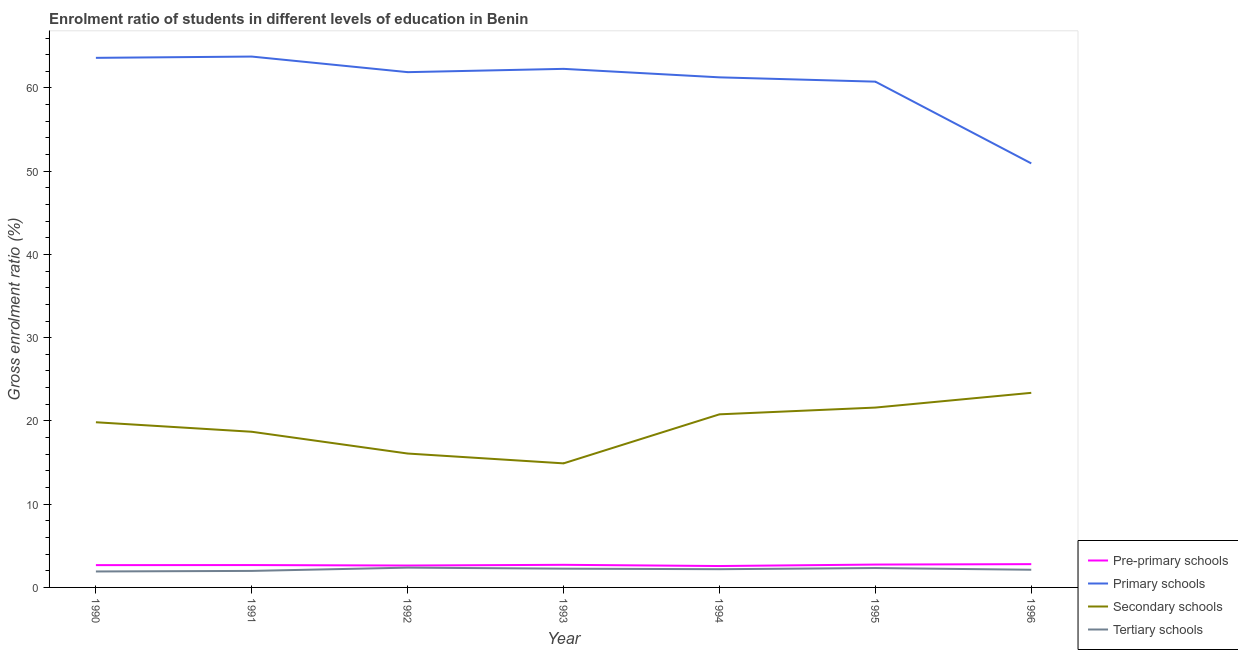Does the line corresponding to gross enrolment ratio in secondary schools intersect with the line corresponding to gross enrolment ratio in pre-primary schools?
Give a very brief answer. No. Is the number of lines equal to the number of legend labels?
Give a very brief answer. Yes. What is the gross enrolment ratio in secondary schools in 1992?
Give a very brief answer. 16.08. Across all years, what is the maximum gross enrolment ratio in primary schools?
Offer a very short reply. 63.77. Across all years, what is the minimum gross enrolment ratio in pre-primary schools?
Your answer should be very brief. 2.57. In which year was the gross enrolment ratio in secondary schools maximum?
Your response must be concise. 1996. What is the total gross enrolment ratio in pre-primary schools in the graph?
Offer a terse response. 18.83. What is the difference between the gross enrolment ratio in primary schools in 1995 and that in 1996?
Your answer should be compact. 9.82. What is the difference between the gross enrolment ratio in primary schools in 1991 and the gross enrolment ratio in secondary schools in 1990?
Your response must be concise. 43.93. What is the average gross enrolment ratio in primary schools per year?
Provide a short and direct response. 60.65. In the year 1992, what is the difference between the gross enrolment ratio in primary schools and gross enrolment ratio in pre-primary schools?
Your response must be concise. 59.27. In how many years, is the gross enrolment ratio in pre-primary schools greater than 22 %?
Provide a succinct answer. 0. What is the ratio of the gross enrolment ratio in secondary schools in 1992 to that in 1993?
Keep it short and to the point. 1.08. Is the gross enrolment ratio in secondary schools in 1993 less than that in 1995?
Your answer should be very brief. Yes. What is the difference between the highest and the second highest gross enrolment ratio in primary schools?
Keep it short and to the point. 0.15. What is the difference between the highest and the lowest gross enrolment ratio in secondary schools?
Make the answer very short. 8.47. In how many years, is the gross enrolment ratio in secondary schools greater than the average gross enrolment ratio in secondary schools taken over all years?
Ensure brevity in your answer.  4. Does the gross enrolment ratio in primary schools monotonically increase over the years?
Give a very brief answer. No. Is the gross enrolment ratio in secondary schools strictly greater than the gross enrolment ratio in tertiary schools over the years?
Your answer should be very brief. Yes. Is the gross enrolment ratio in secondary schools strictly less than the gross enrolment ratio in tertiary schools over the years?
Offer a terse response. No. How many lines are there?
Offer a terse response. 4. What is the difference between two consecutive major ticks on the Y-axis?
Offer a very short reply. 10. Are the values on the major ticks of Y-axis written in scientific E-notation?
Your response must be concise. No. Does the graph contain any zero values?
Offer a terse response. No. Does the graph contain grids?
Your response must be concise. No. What is the title of the graph?
Your answer should be compact. Enrolment ratio of students in different levels of education in Benin. Does "Luxembourg" appear as one of the legend labels in the graph?
Keep it short and to the point. No. What is the Gross enrolment ratio (%) in Pre-primary schools in 1990?
Ensure brevity in your answer.  2.68. What is the Gross enrolment ratio (%) of Primary schools in 1990?
Your answer should be very brief. 63.62. What is the Gross enrolment ratio (%) of Secondary schools in 1990?
Offer a very short reply. 19.84. What is the Gross enrolment ratio (%) in Tertiary schools in 1990?
Your answer should be very brief. 1.92. What is the Gross enrolment ratio (%) of Pre-primary schools in 1991?
Your answer should be very brief. 2.69. What is the Gross enrolment ratio (%) in Primary schools in 1991?
Your answer should be very brief. 63.77. What is the Gross enrolment ratio (%) of Secondary schools in 1991?
Keep it short and to the point. 18.7. What is the Gross enrolment ratio (%) in Tertiary schools in 1991?
Your response must be concise. 1.98. What is the Gross enrolment ratio (%) of Pre-primary schools in 1992?
Keep it short and to the point. 2.63. What is the Gross enrolment ratio (%) in Primary schools in 1992?
Offer a terse response. 61.9. What is the Gross enrolment ratio (%) of Secondary schools in 1992?
Your response must be concise. 16.08. What is the Gross enrolment ratio (%) in Tertiary schools in 1992?
Give a very brief answer. 2.38. What is the Gross enrolment ratio (%) in Pre-primary schools in 1993?
Provide a short and direct response. 2.72. What is the Gross enrolment ratio (%) of Primary schools in 1993?
Ensure brevity in your answer.  62.29. What is the Gross enrolment ratio (%) in Secondary schools in 1993?
Your answer should be compact. 14.9. What is the Gross enrolment ratio (%) in Tertiary schools in 1993?
Your answer should be compact. 2.26. What is the Gross enrolment ratio (%) in Pre-primary schools in 1994?
Keep it short and to the point. 2.57. What is the Gross enrolment ratio (%) of Primary schools in 1994?
Provide a succinct answer. 61.28. What is the Gross enrolment ratio (%) in Secondary schools in 1994?
Your response must be concise. 20.79. What is the Gross enrolment ratio (%) of Tertiary schools in 1994?
Offer a very short reply. 2.19. What is the Gross enrolment ratio (%) in Pre-primary schools in 1995?
Provide a succinct answer. 2.75. What is the Gross enrolment ratio (%) of Primary schools in 1995?
Ensure brevity in your answer.  60.76. What is the Gross enrolment ratio (%) in Secondary schools in 1995?
Provide a succinct answer. 21.61. What is the Gross enrolment ratio (%) in Tertiary schools in 1995?
Keep it short and to the point. 2.33. What is the Gross enrolment ratio (%) in Pre-primary schools in 1996?
Offer a very short reply. 2.8. What is the Gross enrolment ratio (%) in Primary schools in 1996?
Your answer should be compact. 50.94. What is the Gross enrolment ratio (%) of Secondary schools in 1996?
Your answer should be compact. 23.38. What is the Gross enrolment ratio (%) in Tertiary schools in 1996?
Give a very brief answer. 2.12. Across all years, what is the maximum Gross enrolment ratio (%) of Pre-primary schools?
Offer a terse response. 2.8. Across all years, what is the maximum Gross enrolment ratio (%) of Primary schools?
Offer a terse response. 63.77. Across all years, what is the maximum Gross enrolment ratio (%) of Secondary schools?
Provide a succinct answer. 23.38. Across all years, what is the maximum Gross enrolment ratio (%) of Tertiary schools?
Your answer should be very brief. 2.38. Across all years, what is the minimum Gross enrolment ratio (%) in Pre-primary schools?
Provide a succinct answer. 2.57. Across all years, what is the minimum Gross enrolment ratio (%) of Primary schools?
Provide a succinct answer. 50.94. Across all years, what is the minimum Gross enrolment ratio (%) of Secondary schools?
Keep it short and to the point. 14.9. Across all years, what is the minimum Gross enrolment ratio (%) of Tertiary schools?
Provide a succinct answer. 1.92. What is the total Gross enrolment ratio (%) in Pre-primary schools in the graph?
Offer a terse response. 18.83. What is the total Gross enrolment ratio (%) in Primary schools in the graph?
Offer a terse response. 424.55. What is the total Gross enrolment ratio (%) in Secondary schools in the graph?
Offer a very short reply. 135.3. What is the total Gross enrolment ratio (%) in Tertiary schools in the graph?
Make the answer very short. 15.17. What is the difference between the Gross enrolment ratio (%) in Pre-primary schools in 1990 and that in 1991?
Offer a very short reply. -0.01. What is the difference between the Gross enrolment ratio (%) of Primary schools in 1990 and that in 1991?
Give a very brief answer. -0.15. What is the difference between the Gross enrolment ratio (%) in Secondary schools in 1990 and that in 1991?
Your answer should be compact. 1.14. What is the difference between the Gross enrolment ratio (%) in Tertiary schools in 1990 and that in 1991?
Give a very brief answer. -0.07. What is the difference between the Gross enrolment ratio (%) in Pre-primary schools in 1990 and that in 1992?
Ensure brevity in your answer.  0.05. What is the difference between the Gross enrolment ratio (%) in Primary schools in 1990 and that in 1992?
Your answer should be very brief. 1.72. What is the difference between the Gross enrolment ratio (%) of Secondary schools in 1990 and that in 1992?
Keep it short and to the point. 3.76. What is the difference between the Gross enrolment ratio (%) of Tertiary schools in 1990 and that in 1992?
Keep it short and to the point. -0.46. What is the difference between the Gross enrolment ratio (%) of Pre-primary schools in 1990 and that in 1993?
Your answer should be compact. -0.04. What is the difference between the Gross enrolment ratio (%) in Primary schools in 1990 and that in 1993?
Your response must be concise. 1.32. What is the difference between the Gross enrolment ratio (%) of Secondary schools in 1990 and that in 1993?
Offer a terse response. 4.94. What is the difference between the Gross enrolment ratio (%) of Tertiary schools in 1990 and that in 1993?
Your answer should be compact. -0.34. What is the difference between the Gross enrolment ratio (%) of Pre-primary schools in 1990 and that in 1994?
Provide a short and direct response. 0.11. What is the difference between the Gross enrolment ratio (%) of Primary schools in 1990 and that in 1994?
Make the answer very short. 2.34. What is the difference between the Gross enrolment ratio (%) in Secondary schools in 1990 and that in 1994?
Make the answer very short. -0.95. What is the difference between the Gross enrolment ratio (%) in Tertiary schools in 1990 and that in 1994?
Offer a terse response. -0.27. What is the difference between the Gross enrolment ratio (%) of Pre-primary schools in 1990 and that in 1995?
Make the answer very short. -0.07. What is the difference between the Gross enrolment ratio (%) of Primary schools in 1990 and that in 1995?
Ensure brevity in your answer.  2.86. What is the difference between the Gross enrolment ratio (%) of Secondary schools in 1990 and that in 1995?
Offer a terse response. -1.76. What is the difference between the Gross enrolment ratio (%) of Tertiary schools in 1990 and that in 1995?
Your response must be concise. -0.41. What is the difference between the Gross enrolment ratio (%) in Pre-primary schools in 1990 and that in 1996?
Your answer should be compact. -0.12. What is the difference between the Gross enrolment ratio (%) in Primary schools in 1990 and that in 1996?
Give a very brief answer. 12.68. What is the difference between the Gross enrolment ratio (%) of Secondary schools in 1990 and that in 1996?
Provide a short and direct response. -3.53. What is the difference between the Gross enrolment ratio (%) in Tertiary schools in 1990 and that in 1996?
Make the answer very short. -0.21. What is the difference between the Gross enrolment ratio (%) in Pre-primary schools in 1991 and that in 1992?
Ensure brevity in your answer.  0.06. What is the difference between the Gross enrolment ratio (%) in Primary schools in 1991 and that in 1992?
Your response must be concise. 1.87. What is the difference between the Gross enrolment ratio (%) in Secondary schools in 1991 and that in 1992?
Ensure brevity in your answer.  2.62. What is the difference between the Gross enrolment ratio (%) in Tertiary schools in 1991 and that in 1992?
Your answer should be compact. -0.39. What is the difference between the Gross enrolment ratio (%) in Pre-primary schools in 1991 and that in 1993?
Keep it short and to the point. -0.03. What is the difference between the Gross enrolment ratio (%) of Primary schools in 1991 and that in 1993?
Give a very brief answer. 1.48. What is the difference between the Gross enrolment ratio (%) in Secondary schools in 1991 and that in 1993?
Provide a succinct answer. 3.8. What is the difference between the Gross enrolment ratio (%) in Tertiary schools in 1991 and that in 1993?
Offer a terse response. -0.27. What is the difference between the Gross enrolment ratio (%) of Pre-primary schools in 1991 and that in 1994?
Offer a terse response. 0.12. What is the difference between the Gross enrolment ratio (%) of Primary schools in 1991 and that in 1994?
Make the answer very short. 2.5. What is the difference between the Gross enrolment ratio (%) in Secondary schools in 1991 and that in 1994?
Give a very brief answer. -2.09. What is the difference between the Gross enrolment ratio (%) of Tertiary schools in 1991 and that in 1994?
Provide a succinct answer. -0.2. What is the difference between the Gross enrolment ratio (%) in Pre-primary schools in 1991 and that in 1995?
Offer a terse response. -0.06. What is the difference between the Gross enrolment ratio (%) of Primary schools in 1991 and that in 1995?
Make the answer very short. 3.01. What is the difference between the Gross enrolment ratio (%) in Secondary schools in 1991 and that in 1995?
Ensure brevity in your answer.  -2.91. What is the difference between the Gross enrolment ratio (%) of Tertiary schools in 1991 and that in 1995?
Make the answer very short. -0.34. What is the difference between the Gross enrolment ratio (%) in Pre-primary schools in 1991 and that in 1996?
Make the answer very short. -0.11. What is the difference between the Gross enrolment ratio (%) of Primary schools in 1991 and that in 1996?
Keep it short and to the point. 12.83. What is the difference between the Gross enrolment ratio (%) of Secondary schools in 1991 and that in 1996?
Give a very brief answer. -4.68. What is the difference between the Gross enrolment ratio (%) in Tertiary schools in 1991 and that in 1996?
Keep it short and to the point. -0.14. What is the difference between the Gross enrolment ratio (%) in Pre-primary schools in 1992 and that in 1993?
Your answer should be very brief. -0.09. What is the difference between the Gross enrolment ratio (%) of Primary schools in 1992 and that in 1993?
Offer a very short reply. -0.4. What is the difference between the Gross enrolment ratio (%) of Secondary schools in 1992 and that in 1993?
Give a very brief answer. 1.18. What is the difference between the Gross enrolment ratio (%) of Tertiary schools in 1992 and that in 1993?
Your answer should be very brief. 0.12. What is the difference between the Gross enrolment ratio (%) in Pre-primary schools in 1992 and that in 1994?
Provide a succinct answer. 0.06. What is the difference between the Gross enrolment ratio (%) of Primary schools in 1992 and that in 1994?
Provide a short and direct response. 0.62. What is the difference between the Gross enrolment ratio (%) of Secondary schools in 1992 and that in 1994?
Your answer should be compact. -4.71. What is the difference between the Gross enrolment ratio (%) of Tertiary schools in 1992 and that in 1994?
Your answer should be very brief. 0.19. What is the difference between the Gross enrolment ratio (%) of Pre-primary schools in 1992 and that in 1995?
Your response must be concise. -0.12. What is the difference between the Gross enrolment ratio (%) in Primary schools in 1992 and that in 1995?
Give a very brief answer. 1.14. What is the difference between the Gross enrolment ratio (%) in Secondary schools in 1992 and that in 1995?
Provide a short and direct response. -5.52. What is the difference between the Gross enrolment ratio (%) of Tertiary schools in 1992 and that in 1995?
Offer a terse response. 0.05. What is the difference between the Gross enrolment ratio (%) of Pre-primary schools in 1992 and that in 1996?
Your response must be concise. -0.17. What is the difference between the Gross enrolment ratio (%) of Primary schools in 1992 and that in 1996?
Your answer should be compact. 10.96. What is the difference between the Gross enrolment ratio (%) in Secondary schools in 1992 and that in 1996?
Your response must be concise. -7.29. What is the difference between the Gross enrolment ratio (%) of Tertiary schools in 1992 and that in 1996?
Your answer should be compact. 0.26. What is the difference between the Gross enrolment ratio (%) of Pre-primary schools in 1993 and that in 1994?
Your answer should be very brief. 0.15. What is the difference between the Gross enrolment ratio (%) of Primary schools in 1993 and that in 1994?
Ensure brevity in your answer.  1.02. What is the difference between the Gross enrolment ratio (%) in Secondary schools in 1993 and that in 1994?
Ensure brevity in your answer.  -5.89. What is the difference between the Gross enrolment ratio (%) of Tertiary schools in 1993 and that in 1994?
Make the answer very short. 0.07. What is the difference between the Gross enrolment ratio (%) of Pre-primary schools in 1993 and that in 1995?
Provide a succinct answer. -0.03. What is the difference between the Gross enrolment ratio (%) of Primary schools in 1993 and that in 1995?
Make the answer very short. 1.54. What is the difference between the Gross enrolment ratio (%) in Secondary schools in 1993 and that in 1995?
Offer a very short reply. -6.7. What is the difference between the Gross enrolment ratio (%) of Tertiary schools in 1993 and that in 1995?
Your answer should be compact. -0.07. What is the difference between the Gross enrolment ratio (%) of Pre-primary schools in 1993 and that in 1996?
Offer a very short reply. -0.08. What is the difference between the Gross enrolment ratio (%) of Primary schools in 1993 and that in 1996?
Your answer should be compact. 11.36. What is the difference between the Gross enrolment ratio (%) of Secondary schools in 1993 and that in 1996?
Provide a short and direct response. -8.47. What is the difference between the Gross enrolment ratio (%) of Tertiary schools in 1993 and that in 1996?
Make the answer very short. 0.13. What is the difference between the Gross enrolment ratio (%) in Pre-primary schools in 1994 and that in 1995?
Offer a terse response. -0.18. What is the difference between the Gross enrolment ratio (%) of Primary schools in 1994 and that in 1995?
Provide a short and direct response. 0.52. What is the difference between the Gross enrolment ratio (%) of Secondary schools in 1994 and that in 1995?
Provide a succinct answer. -0.81. What is the difference between the Gross enrolment ratio (%) of Tertiary schools in 1994 and that in 1995?
Offer a terse response. -0.14. What is the difference between the Gross enrolment ratio (%) of Pre-primary schools in 1994 and that in 1996?
Ensure brevity in your answer.  -0.23. What is the difference between the Gross enrolment ratio (%) in Primary schools in 1994 and that in 1996?
Ensure brevity in your answer.  10.34. What is the difference between the Gross enrolment ratio (%) of Secondary schools in 1994 and that in 1996?
Ensure brevity in your answer.  -2.58. What is the difference between the Gross enrolment ratio (%) in Tertiary schools in 1994 and that in 1996?
Make the answer very short. 0.07. What is the difference between the Gross enrolment ratio (%) in Pre-primary schools in 1995 and that in 1996?
Your answer should be very brief. -0.05. What is the difference between the Gross enrolment ratio (%) in Primary schools in 1995 and that in 1996?
Provide a succinct answer. 9.82. What is the difference between the Gross enrolment ratio (%) in Secondary schools in 1995 and that in 1996?
Your response must be concise. -1.77. What is the difference between the Gross enrolment ratio (%) in Tertiary schools in 1995 and that in 1996?
Your answer should be very brief. 0.21. What is the difference between the Gross enrolment ratio (%) in Pre-primary schools in 1990 and the Gross enrolment ratio (%) in Primary schools in 1991?
Keep it short and to the point. -61.09. What is the difference between the Gross enrolment ratio (%) of Pre-primary schools in 1990 and the Gross enrolment ratio (%) of Secondary schools in 1991?
Offer a terse response. -16.02. What is the difference between the Gross enrolment ratio (%) of Pre-primary schools in 1990 and the Gross enrolment ratio (%) of Tertiary schools in 1991?
Your answer should be very brief. 0.69. What is the difference between the Gross enrolment ratio (%) in Primary schools in 1990 and the Gross enrolment ratio (%) in Secondary schools in 1991?
Make the answer very short. 44.92. What is the difference between the Gross enrolment ratio (%) of Primary schools in 1990 and the Gross enrolment ratio (%) of Tertiary schools in 1991?
Keep it short and to the point. 61.63. What is the difference between the Gross enrolment ratio (%) of Secondary schools in 1990 and the Gross enrolment ratio (%) of Tertiary schools in 1991?
Your response must be concise. 17.86. What is the difference between the Gross enrolment ratio (%) in Pre-primary schools in 1990 and the Gross enrolment ratio (%) in Primary schools in 1992?
Make the answer very short. -59.22. What is the difference between the Gross enrolment ratio (%) of Pre-primary schools in 1990 and the Gross enrolment ratio (%) of Secondary schools in 1992?
Offer a very short reply. -13.4. What is the difference between the Gross enrolment ratio (%) in Pre-primary schools in 1990 and the Gross enrolment ratio (%) in Tertiary schools in 1992?
Your answer should be compact. 0.3. What is the difference between the Gross enrolment ratio (%) of Primary schools in 1990 and the Gross enrolment ratio (%) of Secondary schools in 1992?
Provide a short and direct response. 47.53. What is the difference between the Gross enrolment ratio (%) in Primary schools in 1990 and the Gross enrolment ratio (%) in Tertiary schools in 1992?
Ensure brevity in your answer.  61.24. What is the difference between the Gross enrolment ratio (%) of Secondary schools in 1990 and the Gross enrolment ratio (%) of Tertiary schools in 1992?
Provide a short and direct response. 17.46. What is the difference between the Gross enrolment ratio (%) of Pre-primary schools in 1990 and the Gross enrolment ratio (%) of Primary schools in 1993?
Your answer should be compact. -59.62. What is the difference between the Gross enrolment ratio (%) of Pre-primary schools in 1990 and the Gross enrolment ratio (%) of Secondary schools in 1993?
Keep it short and to the point. -12.22. What is the difference between the Gross enrolment ratio (%) in Pre-primary schools in 1990 and the Gross enrolment ratio (%) in Tertiary schools in 1993?
Offer a terse response. 0.42. What is the difference between the Gross enrolment ratio (%) of Primary schools in 1990 and the Gross enrolment ratio (%) of Secondary schools in 1993?
Your answer should be very brief. 48.71. What is the difference between the Gross enrolment ratio (%) in Primary schools in 1990 and the Gross enrolment ratio (%) in Tertiary schools in 1993?
Your answer should be compact. 61.36. What is the difference between the Gross enrolment ratio (%) in Secondary schools in 1990 and the Gross enrolment ratio (%) in Tertiary schools in 1993?
Offer a very short reply. 17.59. What is the difference between the Gross enrolment ratio (%) in Pre-primary schools in 1990 and the Gross enrolment ratio (%) in Primary schools in 1994?
Your answer should be compact. -58.6. What is the difference between the Gross enrolment ratio (%) in Pre-primary schools in 1990 and the Gross enrolment ratio (%) in Secondary schools in 1994?
Provide a succinct answer. -18.11. What is the difference between the Gross enrolment ratio (%) in Pre-primary schools in 1990 and the Gross enrolment ratio (%) in Tertiary schools in 1994?
Your answer should be compact. 0.49. What is the difference between the Gross enrolment ratio (%) of Primary schools in 1990 and the Gross enrolment ratio (%) of Secondary schools in 1994?
Provide a succinct answer. 42.82. What is the difference between the Gross enrolment ratio (%) in Primary schools in 1990 and the Gross enrolment ratio (%) in Tertiary schools in 1994?
Provide a succinct answer. 61.43. What is the difference between the Gross enrolment ratio (%) in Secondary schools in 1990 and the Gross enrolment ratio (%) in Tertiary schools in 1994?
Make the answer very short. 17.65. What is the difference between the Gross enrolment ratio (%) of Pre-primary schools in 1990 and the Gross enrolment ratio (%) of Primary schools in 1995?
Offer a terse response. -58.08. What is the difference between the Gross enrolment ratio (%) of Pre-primary schools in 1990 and the Gross enrolment ratio (%) of Secondary schools in 1995?
Give a very brief answer. -18.93. What is the difference between the Gross enrolment ratio (%) of Pre-primary schools in 1990 and the Gross enrolment ratio (%) of Tertiary schools in 1995?
Your answer should be compact. 0.35. What is the difference between the Gross enrolment ratio (%) in Primary schools in 1990 and the Gross enrolment ratio (%) in Secondary schools in 1995?
Keep it short and to the point. 42.01. What is the difference between the Gross enrolment ratio (%) of Primary schools in 1990 and the Gross enrolment ratio (%) of Tertiary schools in 1995?
Give a very brief answer. 61.29. What is the difference between the Gross enrolment ratio (%) in Secondary schools in 1990 and the Gross enrolment ratio (%) in Tertiary schools in 1995?
Offer a terse response. 17.51. What is the difference between the Gross enrolment ratio (%) of Pre-primary schools in 1990 and the Gross enrolment ratio (%) of Primary schools in 1996?
Make the answer very short. -48.26. What is the difference between the Gross enrolment ratio (%) of Pre-primary schools in 1990 and the Gross enrolment ratio (%) of Secondary schools in 1996?
Provide a succinct answer. -20.7. What is the difference between the Gross enrolment ratio (%) of Pre-primary schools in 1990 and the Gross enrolment ratio (%) of Tertiary schools in 1996?
Your answer should be compact. 0.56. What is the difference between the Gross enrolment ratio (%) in Primary schools in 1990 and the Gross enrolment ratio (%) in Secondary schools in 1996?
Provide a short and direct response. 40.24. What is the difference between the Gross enrolment ratio (%) in Primary schools in 1990 and the Gross enrolment ratio (%) in Tertiary schools in 1996?
Offer a terse response. 61.5. What is the difference between the Gross enrolment ratio (%) in Secondary schools in 1990 and the Gross enrolment ratio (%) in Tertiary schools in 1996?
Give a very brief answer. 17.72. What is the difference between the Gross enrolment ratio (%) in Pre-primary schools in 1991 and the Gross enrolment ratio (%) in Primary schools in 1992?
Ensure brevity in your answer.  -59.21. What is the difference between the Gross enrolment ratio (%) of Pre-primary schools in 1991 and the Gross enrolment ratio (%) of Secondary schools in 1992?
Make the answer very short. -13.4. What is the difference between the Gross enrolment ratio (%) of Pre-primary schools in 1991 and the Gross enrolment ratio (%) of Tertiary schools in 1992?
Offer a terse response. 0.31. What is the difference between the Gross enrolment ratio (%) in Primary schools in 1991 and the Gross enrolment ratio (%) in Secondary schools in 1992?
Your response must be concise. 47.69. What is the difference between the Gross enrolment ratio (%) of Primary schools in 1991 and the Gross enrolment ratio (%) of Tertiary schools in 1992?
Offer a very short reply. 61.39. What is the difference between the Gross enrolment ratio (%) of Secondary schools in 1991 and the Gross enrolment ratio (%) of Tertiary schools in 1992?
Offer a terse response. 16.32. What is the difference between the Gross enrolment ratio (%) in Pre-primary schools in 1991 and the Gross enrolment ratio (%) in Primary schools in 1993?
Provide a short and direct response. -59.61. What is the difference between the Gross enrolment ratio (%) in Pre-primary schools in 1991 and the Gross enrolment ratio (%) in Secondary schools in 1993?
Make the answer very short. -12.22. What is the difference between the Gross enrolment ratio (%) in Pre-primary schools in 1991 and the Gross enrolment ratio (%) in Tertiary schools in 1993?
Your answer should be very brief. 0.43. What is the difference between the Gross enrolment ratio (%) of Primary schools in 1991 and the Gross enrolment ratio (%) of Secondary schools in 1993?
Provide a short and direct response. 48.87. What is the difference between the Gross enrolment ratio (%) in Primary schools in 1991 and the Gross enrolment ratio (%) in Tertiary schools in 1993?
Ensure brevity in your answer.  61.52. What is the difference between the Gross enrolment ratio (%) of Secondary schools in 1991 and the Gross enrolment ratio (%) of Tertiary schools in 1993?
Provide a succinct answer. 16.44. What is the difference between the Gross enrolment ratio (%) in Pre-primary schools in 1991 and the Gross enrolment ratio (%) in Primary schools in 1994?
Provide a short and direct response. -58.59. What is the difference between the Gross enrolment ratio (%) of Pre-primary schools in 1991 and the Gross enrolment ratio (%) of Secondary schools in 1994?
Give a very brief answer. -18.11. What is the difference between the Gross enrolment ratio (%) of Pre-primary schools in 1991 and the Gross enrolment ratio (%) of Tertiary schools in 1994?
Your response must be concise. 0.5. What is the difference between the Gross enrolment ratio (%) in Primary schools in 1991 and the Gross enrolment ratio (%) in Secondary schools in 1994?
Your answer should be compact. 42.98. What is the difference between the Gross enrolment ratio (%) of Primary schools in 1991 and the Gross enrolment ratio (%) of Tertiary schools in 1994?
Offer a very short reply. 61.58. What is the difference between the Gross enrolment ratio (%) of Secondary schools in 1991 and the Gross enrolment ratio (%) of Tertiary schools in 1994?
Your answer should be very brief. 16.51. What is the difference between the Gross enrolment ratio (%) in Pre-primary schools in 1991 and the Gross enrolment ratio (%) in Primary schools in 1995?
Keep it short and to the point. -58.07. What is the difference between the Gross enrolment ratio (%) in Pre-primary schools in 1991 and the Gross enrolment ratio (%) in Secondary schools in 1995?
Keep it short and to the point. -18.92. What is the difference between the Gross enrolment ratio (%) in Pre-primary schools in 1991 and the Gross enrolment ratio (%) in Tertiary schools in 1995?
Your answer should be very brief. 0.36. What is the difference between the Gross enrolment ratio (%) in Primary schools in 1991 and the Gross enrolment ratio (%) in Secondary schools in 1995?
Provide a succinct answer. 42.16. What is the difference between the Gross enrolment ratio (%) of Primary schools in 1991 and the Gross enrolment ratio (%) of Tertiary schools in 1995?
Offer a very short reply. 61.44. What is the difference between the Gross enrolment ratio (%) of Secondary schools in 1991 and the Gross enrolment ratio (%) of Tertiary schools in 1995?
Provide a short and direct response. 16.37. What is the difference between the Gross enrolment ratio (%) of Pre-primary schools in 1991 and the Gross enrolment ratio (%) of Primary schools in 1996?
Your answer should be compact. -48.25. What is the difference between the Gross enrolment ratio (%) of Pre-primary schools in 1991 and the Gross enrolment ratio (%) of Secondary schools in 1996?
Give a very brief answer. -20.69. What is the difference between the Gross enrolment ratio (%) of Pre-primary schools in 1991 and the Gross enrolment ratio (%) of Tertiary schools in 1996?
Your response must be concise. 0.56. What is the difference between the Gross enrolment ratio (%) of Primary schools in 1991 and the Gross enrolment ratio (%) of Secondary schools in 1996?
Keep it short and to the point. 40.39. What is the difference between the Gross enrolment ratio (%) of Primary schools in 1991 and the Gross enrolment ratio (%) of Tertiary schools in 1996?
Provide a succinct answer. 61.65. What is the difference between the Gross enrolment ratio (%) of Secondary schools in 1991 and the Gross enrolment ratio (%) of Tertiary schools in 1996?
Make the answer very short. 16.58. What is the difference between the Gross enrolment ratio (%) in Pre-primary schools in 1992 and the Gross enrolment ratio (%) in Primary schools in 1993?
Your answer should be compact. -59.66. What is the difference between the Gross enrolment ratio (%) in Pre-primary schools in 1992 and the Gross enrolment ratio (%) in Secondary schools in 1993?
Provide a succinct answer. -12.27. What is the difference between the Gross enrolment ratio (%) of Pre-primary schools in 1992 and the Gross enrolment ratio (%) of Tertiary schools in 1993?
Your answer should be compact. 0.37. What is the difference between the Gross enrolment ratio (%) of Primary schools in 1992 and the Gross enrolment ratio (%) of Secondary schools in 1993?
Your answer should be compact. 47. What is the difference between the Gross enrolment ratio (%) in Primary schools in 1992 and the Gross enrolment ratio (%) in Tertiary schools in 1993?
Your response must be concise. 59.64. What is the difference between the Gross enrolment ratio (%) in Secondary schools in 1992 and the Gross enrolment ratio (%) in Tertiary schools in 1993?
Give a very brief answer. 13.83. What is the difference between the Gross enrolment ratio (%) of Pre-primary schools in 1992 and the Gross enrolment ratio (%) of Primary schools in 1994?
Keep it short and to the point. -58.65. What is the difference between the Gross enrolment ratio (%) in Pre-primary schools in 1992 and the Gross enrolment ratio (%) in Secondary schools in 1994?
Keep it short and to the point. -18.16. What is the difference between the Gross enrolment ratio (%) of Pre-primary schools in 1992 and the Gross enrolment ratio (%) of Tertiary schools in 1994?
Keep it short and to the point. 0.44. What is the difference between the Gross enrolment ratio (%) in Primary schools in 1992 and the Gross enrolment ratio (%) in Secondary schools in 1994?
Keep it short and to the point. 41.1. What is the difference between the Gross enrolment ratio (%) in Primary schools in 1992 and the Gross enrolment ratio (%) in Tertiary schools in 1994?
Provide a short and direct response. 59.71. What is the difference between the Gross enrolment ratio (%) in Secondary schools in 1992 and the Gross enrolment ratio (%) in Tertiary schools in 1994?
Give a very brief answer. 13.9. What is the difference between the Gross enrolment ratio (%) in Pre-primary schools in 1992 and the Gross enrolment ratio (%) in Primary schools in 1995?
Provide a succinct answer. -58.13. What is the difference between the Gross enrolment ratio (%) of Pre-primary schools in 1992 and the Gross enrolment ratio (%) of Secondary schools in 1995?
Your response must be concise. -18.98. What is the difference between the Gross enrolment ratio (%) of Pre-primary schools in 1992 and the Gross enrolment ratio (%) of Tertiary schools in 1995?
Provide a short and direct response. 0.3. What is the difference between the Gross enrolment ratio (%) in Primary schools in 1992 and the Gross enrolment ratio (%) in Secondary schools in 1995?
Offer a very short reply. 40.29. What is the difference between the Gross enrolment ratio (%) of Primary schools in 1992 and the Gross enrolment ratio (%) of Tertiary schools in 1995?
Offer a terse response. 59.57. What is the difference between the Gross enrolment ratio (%) in Secondary schools in 1992 and the Gross enrolment ratio (%) in Tertiary schools in 1995?
Provide a succinct answer. 13.76. What is the difference between the Gross enrolment ratio (%) of Pre-primary schools in 1992 and the Gross enrolment ratio (%) of Primary schools in 1996?
Provide a short and direct response. -48.31. What is the difference between the Gross enrolment ratio (%) of Pre-primary schools in 1992 and the Gross enrolment ratio (%) of Secondary schools in 1996?
Your answer should be very brief. -20.75. What is the difference between the Gross enrolment ratio (%) of Pre-primary schools in 1992 and the Gross enrolment ratio (%) of Tertiary schools in 1996?
Your answer should be very brief. 0.51. What is the difference between the Gross enrolment ratio (%) of Primary schools in 1992 and the Gross enrolment ratio (%) of Secondary schools in 1996?
Provide a succinct answer. 38.52. What is the difference between the Gross enrolment ratio (%) of Primary schools in 1992 and the Gross enrolment ratio (%) of Tertiary schools in 1996?
Ensure brevity in your answer.  59.78. What is the difference between the Gross enrolment ratio (%) of Secondary schools in 1992 and the Gross enrolment ratio (%) of Tertiary schools in 1996?
Offer a terse response. 13.96. What is the difference between the Gross enrolment ratio (%) of Pre-primary schools in 1993 and the Gross enrolment ratio (%) of Primary schools in 1994?
Your answer should be compact. -58.56. What is the difference between the Gross enrolment ratio (%) of Pre-primary schools in 1993 and the Gross enrolment ratio (%) of Secondary schools in 1994?
Provide a succinct answer. -18.08. What is the difference between the Gross enrolment ratio (%) in Pre-primary schools in 1993 and the Gross enrolment ratio (%) in Tertiary schools in 1994?
Keep it short and to the point. 0.53. What is the difference between the Gross enrolment ratio (%) of Primary schools in 1993 and the Gross enrolment ratio (%) of Secondary schools in 1994?
Make the answer very short. 41.5. What is the difference between the Gross enrolment ratio (%) in Primary schools in 1993 and the Gross enrolment ratio (%) in Tertiary schools in 1994?
Ensure brevity in your answer.  60.11. What is the difference between the Gross enrolment ratio (%) in Secondary schools in 1993 and the Gross enrolment ratio (%) in Tertiary schools in 1994?
Offer a very short reply. 12.71. What is the difference between the Gross enrolment ratio (%) in Pre-primary schools in 1993 and the Gross enrolment ratio (%) in Primary schools in 1995?
Provide a succinct answer. -58.04. What is the difference between the Gross enrolment ratio (%) in Pre-primary schools in 1993 and the Gross enrolment ratio (%) in Secondary schools in 1995?
Give a very brief answer. -18.89. What is the difference between the Gross enrolment ratio (%) in Pre-primary schools in 1993 and the Gross enrolment ratio (%) in Tertiary schools in 1995?
Give a very brief answer. 0.39. What is the difference between the Gross enrolment ratio (%) in Primary schools in 1993 and the Gross enrolment ratio (%) in Secondary schools in 1995?
Offer a terse response. 40.69. What is the difference between the Gross enrolment ratio (%) of Primary schools in 1993 and the Gross enrolment ratio (%) of Tertiary schools in 1995?
Keep it short and to the point. 59.97. What is the difference between the Gross enrolment ratio (%) of Secondary schools in 1993 and the Gross enrolment ratio (%) of Tertiary schools in 1995?
Your response must be concise. 12.57. What is the difference between the Gross enrolment ratio (%) in Pre-primary schools in 1993 and the Gross enrolment ratio (%) in Primary schools in 1996?
Your answer should be very brief. -48.22. What is the difference between the Gross enrolment ratio (%) in Pre-primary schools in 1993 and the Gross enrolment ratio (%) in Secondary schools in 1996?
Keep it short and to the point. -20.66. What is the difference between the Gross enrolment ratio (%) in Pre-primary schools in 1993 and the Gross enrolment ratio (%) in Tertiary schools in 1996?
Your answer should be very brief. 0.59. What is the difference between the Gross enrolment ratio (%) in Primary schools in 1993 and the Gross enrolment ratio (%) in Secondary schools in 1996?
Your answer should be very brief. 38.92. What is the difference between the Gross enrolment ratio (%) of Primary schools in 1993 and the Gross enrolment ratio (%) of Tertiary schools in 1996?
Make the answer very short. 60.17. What is the difference between the Gross enrolment ratio (%) of Secondary schools in 1993 and the Gross enrolment ratio (%) of Tertiary schools in 1996?
Your answer should be very brief. 12.78. What is the difference between the Gross enrolment ratio (%) of Pre-primary schools in 1994 and the Gross enrolment ratio (%) of Primary schools in 1995?
Ensure brevity in your answer.  -58.19. What is the difference between the Gross enrolment ratio (%) of Pre-primary schools in 1994 and the Gross enrolment ratio (%) of Secondary schools in 1995?
Your answer should be very brief. -19.04. What is the difference between the Gross enrolment ratio (%) of Pre-primary schools in 1994 and the Gross enrolment ratio (%) of Tertiary schools in 1995?
Give a very brief answer. 0.24. What is the difference between the Gross enrolment ratio (%) in Primary schools in 1994 and the Gross enrolment ratio (%) in Secondary schools in 1995?
Offer a very short reply. 39.67. What is the difference between the Gross enrolment ratio (%) in Primary schools in 1994 and the Gross enrolment ratio (%) in Tertiary schools in 1995?
Offer a terse response. 58.95. What is the difference between the Gross enrolment ratio (%) in Secondary schools in 1994 and the Gross enrolment ratio (%) in Tertiary schools in 1995?
Ensure brevity in your answer.  18.47. What is the difference between the Gross enrolment ratio (%) in Pre-primary schools in 1994 and the Gross enrolment ratio (%) in Primary schools in 1996?
Ensure brevity in your answer.  -48.37. What is the difference between the Gross enrolment ratio (%) in Pre-primary schools in 1994 and the Gross enrolment ratio (%) in Secondary schools in 1996?
Offer a very short reply. -20.81. What is the difference between the Gross enrolment ratio (%) of Pre-primary schools in 1994 and the Gross enrolment ratio (%) of Tertiary schools in 1996?
Your response must be concise. 0.45. What is the difference between the Gross enrolment ratio (%) of Primary schools in 1994 and the Gross enrolment ratio (%) of Secondary schools in 1996?
Your answer should be very brief. 37.9. What is the difference between the Gross enrolment ratio (%) of Primary schools in 1994 and the Gross enrolment ratio (%) of Tertiary schools in 1996?
Your response must be concise. 59.15. What is the difference between the Gross enrolment ratio (%) in Secondary schools in 1994 and the Gross enrolment ratio (%) in Tertiary schools in 1996?
Offer a very short reply. 18.67. What is the difference between the Gross enrolment ratio (%) in Pre-primary schools in 1995 and the Gross enrolment ratio (%) in Primary schools in 1996?
Your response must be concise. -48.19. What is the difference between the Gross enrolment ratio (%) in Pre-primary schools in 1995 and the Gross enrolment ratio (%) in Secondary schools in 1996?
Provide a short and direct response. -20.63. What is the difference between the Gross enrolment ratio (%) in Pre-primary schools in 1995 and the Gross enrolment ratio (%) in Tertiary schools in 1996?
Offer a very short reply. 0.62. What is the difference between the Gross enrolment ratio (%) of Primary schools in 1995 and the Gross enrolment ratio (%) of Secondary schools in 1996?
Keep it short and to the point. 37.38. What is the difference between the Gross enrolment ratio (%) in Primary schools in 1995 and the Gross enrolment ratio (%) in Tertiary schools in 1996?
Offer a very short reply. 58.64. What is the difference between the Gross enrolment ratio (%) in Secondary schools in 1995 and the Gross enrolment ratio (%) in Tertiary schools in 1996?
Your response must be concise. 19.48. What is the average Gross enrolment ratio (%) in Pre-primary schools per year?
Offer a very short reply. 2.69. What is the average Gross enrolment ratio (%) of Primary schools per year?
Offer a terse response. 60.65. What is the average Gross enrolment ratio (%) in Secondary schools per year?
Offer a very short reply. 19.33. What is the average Gross enrolment ratio (%) of Tertiary schools per year?
Your response must be concise. 2.17. In the year 1990, what is the difference between the Gross enrolment ratio (%) in Pre-primary schools and Gross enrolment ratio (%) in Primary schools?
Your response must be concise. -60.94. In the year 1990, what is the difference between the Gross enrolment ratio (%) of Pre-primary schools and Gross enrolment ratio (%) of Secondary schools?
Offer a very short reply. -17.16. In the year 1990, what is the difference between the Gross enrolment ratio (%) in Pre-primary schools and Gross enrolment ratio (%) in Tertiary schools?
Ensure brevity in your answer.  0.76. In the year 1990, what is the difference between the Gross enrolment ratio (%) in Primary schools and Gross enrolment ratio (%) in Secondary schools?
Keep it short and to the point. 43.78. In the year 1990, what is the difference between the Gross enrolment ratio (%) of Primary schools and Gross enrolment ratio (%) of Tertiary schools?
Offer a very short reply. 61.7. In the year 1990, what is the difference between the Gross enrolment ratio (%) in Secondary schools and Gross enrolment ratio (%) in Tertiary schools?
Your response must be concise. 17.92. In the year 1991, what is the difference between the Gross enrolment ratio (%) of Pre-primary schools and Gross enrolment ratio (%) of Primary schools?
Your answer should be compact. -61.08. In the year 1991, what is the difference between the Gross enrolment ratio (%) of Pre-primary schools and Gross enrolment ratio (%) of Secondary schools?
Keep it short and to the point. -16.01. In the year 1991, what is the difference between the Gross enrolment ratio (%) of Pre-primary schools and Gross enrolment ratio (%) of Tertiary schools?
Offer a very short reply. 0.7. In the year 1991, what is the difference between the Gross enrolment ratio (%) in Primary schools and Gross enrolment ratio (%) in Secondary schools?
Make the answer very short. 45.07. In the year 1991, what is the difference between the Gross enrolment ratio (%) of Primary schools and Gross enrolment ratio (%) of Tertiary schools?
Give a very brief answer. 61.79. In the year 1991, what is the difference between the Gross enrolment ratio (%) of Secondary schools and Gross enrolment ratio (%) of Tertiary schools?
Your response must be concise. 16.71. In the year 1992, what is the difference between the Gross enrolment ratio (%) of Pre-primary schools and Gross enrolment ratio (%) of Primary schools?
Provide a short and direct response. -59.27. In the year 1992, what is the difference between the Gross enrolment ratio (%) of Pre-primary schools and Gross enrolment ratio (%) of Secondary schools?
Make the answer very short. -13.45. In the year 1992, what is the difference between the Gross enrolment ratio (%) in Pre-primary schools and Gross enrolment ratio (%) in Tertiary schools?
Your answer should be very brief. 0.25. In the year 1992, what is the difference between the Gross enrolment ratio (%) of Primary schools and Gross enrolment ratio (%) of Secondary schools?
Your answer should be very brief. 45.81. In the year 1992, what is the difference between the Gross enrolment ratio (%) in Primary schools and Gross enrolment ratio (%) in Tertiary schools?
Make the answer very short. 59.52. In the year 1992, what is the difference between the Gross enrolment ratio (%) of Secondary schools and Gross enrolment ratio (%) of Tertiary schools?
Make the answer very short. 13.71. In the year 1993, what is the difference between the Gross enrolment ratio (%) in Pre-primary schools and Gross enrolment ratio (%) in Primary schools?
Your answer should be very brief. -59.58. In the year 1993, what is the difference between the Gross enrolment ratio (%) in Pre-primary schools and Gross enrolment ratio (%) in Secondary schools?
Offer a very short reply. -12.19. In the year 1993, what is the difference between the Gross enrolment ratio (%) in Pre-primary schools and Gross enrolment ratio (%) in Tertiary schools?
Give a very brief answer. 0.46. In the year 1993, what is the difference between the Gross enrolment ratio (%) in Primary schools and Gross enrolment ratio (%) in Secondary schools?
Ensure brevity in your answer.  47.39. In the year 1993, what is the difference between the Gross enrolment ratio (%) of Primary schools and Gross enrolment ratio (%) of Tertiary schools?
Provide a succinct answer. 60.04. In the year 1993, what is the difference between the Gross enrolment ratio (%) in Secondary schools and Gross enrolment ratio (%) in Tertiary schools?
Your response must be concise. 12.65. In the year 1994, what is the difference between the Gross enrolment ratio (%) in Pre-primary schools and Gross enrolment ratio (%) in Primary schools?
Provide a succinct answer. -58.7. In the year 1994, what is the difference between the Gross enrolment ratio (%) of Pre-primary schools and Gross enrolment ratio (%) of Secondary schools?
Provide a short and direct response. -18.22. In the year 1994, what is the difference between the Gross enrolment ratio (%) of Pre-primary schools and Gross enrolment ratio (%) of Tertiary schools?
Your response must be concise. 0.38. In the year 1994, what is the difference between the Gross enrolment ratio (%) in Primary schools and Gross enrolment ratio (%) in Secondary schools?
Offer a terse response. 40.48. In the year 1994, what is the difference between the Gross enrolment ratio (%) in Primary schools and Gross enrolment ratio (%) in Tertiary schools?
Offer a very short reply. 59.09. In the year 1994, what is the difference between the Gross enrolment ratio (%) in Secondary schools and Gross enrolment ratio (%) in Tertiary schools?
Offer a terse response. 18.61. In the year 1995, what is the difference between the Gross enrolment ratio (%) in Pre-primary schools and Gross enrolment ratio (%) in Primary schools?
Offer a very short reply. -58.01. In the year 1995, what is the difference between the Gross enrolment ratio (%) of Pre-primary schools and Gross enrolment ratio (%) of Secondary schools?
Make the answer very short. -18.86. In the year 1995, what is the difference between the Gross enrolment ratio (%) in Pre-primary schools and Gross enrolment ratio (%) in Tertiary schools?
Provide a succinct answer. 0.42. In the year 1995, what is the difference between the Gross enrolment ratio (%) of Primary schools and Gross enrolment ratio (%) of Secondary schools?
Your response must be concise. 39.15. In the year 1995, what is the difference between the Gross enrolment ratio (%) in Primary schools and Gross enrolment ratio (%) in Tertiary schools?
Provide a short and direct response. 58.43. In the year 1995, what is the difference between the Gross enrolment ratio (%) of Secondary schools and Gross enrolment ratio (%) of Tertiary schools?
Ensure brevity in your answer.  19.28. In the year 1996, what is the difference between the Gross enrolment ratio (%) of Pre-primary schools and Gross enrolment ratio (%) of Primary schools?
Offer a very short reply. -48.14. In the year 1996, what is the difference between the Gross enrolment ratio (%) of Pre-primary schools and Gross enrolment ratio (%) of Secondary schools?
Your answer should be compact. -20.58. In the year 1996, what is the difference between the Gross enrolment ratio (%) in Pre-primary schools and Gross enrolment ratio (%) in Tertiary schools?
Your response must be concise. 0.68. In the year 1996, what is the difference between the Gross enrolment ratio (%) of Primary schools and Gross enrolment ratio (%) of Secondary schools?
Make the answer very short. 27.56. In the year 1996, what is the difference between the Gross enrolment ratio (%) in Primary schools and Gross enrolment ratio (%) in Tertiary schools?
Your response must be concise. 48.82. In the year 1996, what is the difference between the Gross enrolment ratio (%) of Secondary schools and Gross enrolment ratio (%) of Tertiary schools?
Your response must be concise. 21.25. What is the ratio of the Gross enrolment ratio (%) of Secondary schools in 1990 to that in 1991?
Make the answer very short. 1.06. What is the ratio of the Gross enrolment ratio (%) of Tertiary schools in 1990 to that in 1991?
Your response must be concise. 0.97. What is the ratio of the Gross enrolment ratio (%) of Pre-primary schools in 1990 to that in 1992?
Your answer should be compact. 1.02. What is the ratio of the Gross enrolment ratio (%) in Primary schools in 1990 to that in 1992?
Offer a terse response. 1.03. What is the ratio of the Gross enrolment ratio (%) in Secondary schools in 1990 to that in 1992?
Your response must be concise. 1.23. What is the ratio of the Gross enrolment ratio (%) in Tertiary schools in 1990 to that in 1992?
Offer a very short reply. 0.81. What is the ratio of the Gross enrolment ratio (%) in Pre-primary schools in 1990 to that in 1993?
Provide a short and direct response. 0.99. What is the ratio of the Gross enrolment ratio (%) of Primary schools in 1990 to that in 1993?
Your answer should be very brief. 1.02. What is the ratio of the Gross enrolment ratio (%) of Secondary schools in 1990 to that in 1993?
Make the answer very short. 1.33. What is the ratio of the Gross enrolment ratio (%) in Pre-primary schools in 1990 to that in 1994?
Give a very brief answer. 1.04. What is the ratio of the Gross enrolment ratio (%) of Primary schools in 1990 to that in 1994?
Offer a terse response. 1.04. What is the ratio of the Gross enrolment ratio (%) in Secondary schools in 1990 to that in 1994?
Your answer should be very brief. 0.95. What is the ratio of the Gross enrolment ratio (%) in Tertiary schools in 1990 to that in 1994?
Give a very brief answer. 0.88. What is the ratio of the Gross enrolment ratio (%) of Pre-primary schools in 1990 to that in 1995?
Make the answer very short. 0.98. What is the ratio of the Gross enrolment ratio (%) of Primary schools in 1990 to that in 1995?
Provide a succinct answer. 1.05. What is the ratio of the Gross enrolment ratio (%) of Secondary schools in 1990 to that in 1995?
Give a very brief answer. 0.92. What is the ratio of the Gross enrolment ratio (%) of Tertiary schools in 1990 to that in 1995?
Offer a very short reply. 0.82. What is the ratio of the Gross enrolment ratio (%) of Pre-primary schools in 1990 to that in 1996?
Give a very brief answer. 0.96. What is the ratio of the Gross enrolment ratio (%) of Primary schools in 1990 to that in 1996?
Your answer should be very brief. 1.25. What is the ratio of the Gross enrolment ratio (%) of Secondary schools in 1990 to that in 1996?
Provide a succinct answer. 0.85. What is the ratio of the Gross enrolment ratio (%) in Tertiary schools in 1990 to that in 1996?
Offer a terse response. 0.9. What is the ratio of the Gross enrolment ratio (%) of Pre-primary schools in 1991 to that in 1992?
Your response must be concise. 1.02. What is the ratio of the Gross enrolment ratio (%) of Primary schools in 1991 to that in 1992?
Give a very brief answer. 1.03. What is the ratio of the Gross enrolment ratio (%) of Secondary schools in 1991 to that in 1992?
Ensure brevity in your answer.  1.16. What is the ratio of the Gross enrolment ratio (%) of Tertiary schools in 1991 to that in 1992?
Offer a terse response. 0.83. What is the ratio of the Gross enrolment ratio (%) of Primary schools in 1991 to that in 1993?
Keep it short and to the point. 1.02. What is the ratio of the Gross enrolment ratio (%) in Secondary schools in 1991 to that in 1993?
Your response must be concise. 1.25. What is the ratio of the Gross enrolment ratio (%) of Tertiary schools in 1991 to that in 1993?
Give a very brief answer. 0.88. What is the ratio of the Gross enrolment ratio (%) in Pre-primary schools in 1991 to that in 1994?
Make the answer very short. 1.04. What is the ratio of the Gross enrolment ratio (%) of Primary schools in 1991 to that in 1994?
Provide a succinct answer. 1.04. What is the ratio of the Gross enrolment ratio (%) in Secondary schools in 1991 to that in 1994?
Your answer should be very brief. 0.9. What is the ratio of the Gross enrolment ratio (%) in Tertiary schools in 1991 to that in 1994?
Provide a short and direct response. 0.91. What is the ratio of the Gross enrolment ratio (%) of Pre-primary schools in 1991 to that in 1995?
Provide a succinct answer. 0.98. What is the ratio of the Gross enrolment ratio (%) in Primary schools in 1991 to that in 1995?
Provide a succinct answer. 1.05. What is the ratio of the Gross enrolment ratio (%) in Secondary schools in 1991 to that in 1995?
Provide a short and direct response. 0.87. What is the ratio of the Gross enrolment ratio (%) in Tertiary schools in 1991 to that in 1995?
Make the answer very short. 0.85. What is the ratio of the Gross enrolment ratio (%) in Primary schools in 1991 to that in 1996?
Ensure brevity in your answer.  1.25. What is the ratio of the Gross enrolment ratio (%) in Secondary schools in 1991 to that in 1996?
Make the answer very short. 0.8. What is the ratio of the Gross enrolment ratio (%) in Tertiary schools in 1991 to that in 1996?
Keep it short and to the point. 0.93. What is the ratio of the Gross enrolment ratio (%) in Pre-primary schools in 1992 to that in 1993?
Ensure brevity in your answer.  0.97. What is the ratio of the Gross enrolment ratio (%) in Secondary schools in 1992 to that in 1993?
Give a very brief answer. 1.08. What is the ratio of the Gross enrolment ratio (%) in Tertiary schools in 1992 to that in 1993?
Offer a very short reply. 1.05. What is the ratio of the Gross enrolment ratio (%) of Pre-primary schools in 1992 to that in 1994?
Ensure brevity in your answer.  1.02. What is the ratio of the Gross enrolment ratio (%) in Primary schools in 1992 to that in 1994?
Ensure brevity in your answer.  1.01. What is the ratio of the Gross enrolment ratio (%) in Secondary schools in 1992 to that in 1994?
Give a very brief answer. 0.77. What is the ratio of the Gross enrolment ratio (%) in Tertiary schools in 1992 to that in 1994?
Make the answer very short. 1.09. What is the ratio of the Gross enrolment ratio (%) in Pre-primary schools in 1992 to that in 1995?
Give a very brief answer. 0.96. What is the ratio of the Gross enrolment ratio (%) of Primary schools in 1992 to that in 1995?
Give a very brief answer. 1.02. What is the ratio of the Gross enrolment ratio (%) in Secondary schools in 1992 to that in 1995?
Your answer should be compact. 0.74. What is the ratio of the Gross enrolment ratio (%) in Tertiary schools in 1992 to that in 1995?
Offer a very short reply. 1.02. What is the ratio of the Gross enrolment ratio (%) of Pre-primary schools in 1992 to that in 1996?
Provide a short and direct response. 0.94. What is the ratio of the Gross enrolment ratio (%) in Primary schools in 1992 to that in 1996?
Offer a very short reply. 1.22. What is the ratio of the Gross enrolment ratio (%) of Secondary schools in 1992 to that in 1996?
Give a very brief answer. 0.69. What is the ratio of the Gross enrolment ratio (%) of Tertiary schools in 1992 to that in 1996?
Keep it short and to the point. 1.12. What is the ratio of the Gross enrolment ratio (%) in Pre-primary schools in 1993 to that in 1994?
Provide a succinct answer. 1.06. What is the ratio of the Gross enrolment ratio (%) of Primary schools in 1993 to that in 1994?
Provide a succinct answer. 1.02. What is the ratio of the Gross enrolment ratio (%) in Secondary schools in 1993 to that in 1994?
Make the answer very short. 0.72. What is the ratio of the Gross enrolment ratio (%) in Tertiary schools in 1993 to that in 1994?
Your answer should be compact. 1.03. What is the ratio of the Gross enrolment ratio (%) of Pre-primary schools in 1993 to that in 1995?
Make the answer very short. 0.99. What is the ratio of the Gross enrolment ratio (%) in Primary schools in 1993 to that in 1995?
Keep it short and to the point. 1.03. What is the ratio of the Gross enrolment ratio (%) of Secondary schools in 1993 to that in 1995?
Make the answer very short. 0.69. What is the ratio of the Gross enrolment ratio (%) in Tertiary schools in 1993 to that in 1995?
Give a very brief answer. 0.97. What is the ratio of the Gross enrolment ratio (%) of Pre-primary schools in 1993 to that in 1996?
Keep it short and to the point. 0.97. What is the ratio of the Gross enrolment ratio (%) in Primary schools in 1993 to that in 1996?
Give a very brief answer. 1.22. What is the ratio of the Gross enrolment ratio (%) in Secondary schools in 1993 to that in 1996?
Offer a very short reply. 0.64. What is the ratio of the Gross enrolment ratio (%) in Tertiary schools in 1993 to that in 1996?
Your answer should be compact. 1.06. What is the ratio of the Gross enrolment ratio (%) in Pre-primary schools in 1994 to that in 1995?
Your response must be concise. 0.94. What is the ratio of the Gross enrolment ratio (%) of Primary schools in 1994 to that in 1995?
Provide a succinct answer. 1.01. What is the ratio of the Gross enrolment ratio (%) in Secondary schools in 1994 to that in 1995?
Offer a terse response. 0.96. What is the ratio of the Gross enrolment ratio (%) of Pre-primary schools in 1994 to that in 1996?
Provide a succinct answer. 0.92. What is the ratio of the Gross enrolment ratio (%) of Primary schools in 1994 to that in 1996?
Your answer should be very brief. 1.2. What is the ratio of the Gross enrolment ratio (%) in Secondary schools in 1994 to that in 1996?
Your answer should be compact. 0.89. What is the ratio of the Gross enrolment ratio (%) in Tertiary schools in 1994 to that in 1996?
Your answer should be compact. 1.03. What is the ratio of the Gross enrolment ratio (%) in Primary schools in 1995 to that in 1996?
Your answer should be compact. 1.19. What is the ratio of the Gross enrolment ratio (%) of Secondary schools in 1995 to that in 1996?
Your response must be concise. 0.92. What is the ratio of the Gross enrolment ratio (%) of Tertiary schools in 1995 to that in 1996?
Provide a short and direct response. 1.1. What is the difference between the highest and the second highest Gross enrolment ratio (%) in Pre-primary schools?
Make the answer very short. 0.05. What is the difference between the highest and the second highest Gross enrolment ratio (%) of Primary schools?
Offer a very short reply. 0.15. What is the difference between the highest and the second highest Gross enrolment ratio (%) in Secondary schools?
Ensure brevity in your answer.  1.77. What is the difference between the highest and the second highest Gross enrolment ratio (%) of Tertiary schools?
Provide a short and direct response. 0.05. What is the difference between the highest and the lowest Gross enrolment ratio (%) in Pre-primary schools?
Give a very brief answer. 0.23. What is the difference between the highest and the lowest Gross enrolment ratio (%) in Primary schools?
Give a very brief answer. 12.83. What is the difference between the highest and the lowest Gross enrolment ratio (%) of Secondary schools?
Offer a terse response. 8.47. What is the difference between the highest and the lowest Gross enrolment ratio (%) in Tertiary schools?
Your answer should be very brief. 0.46. 